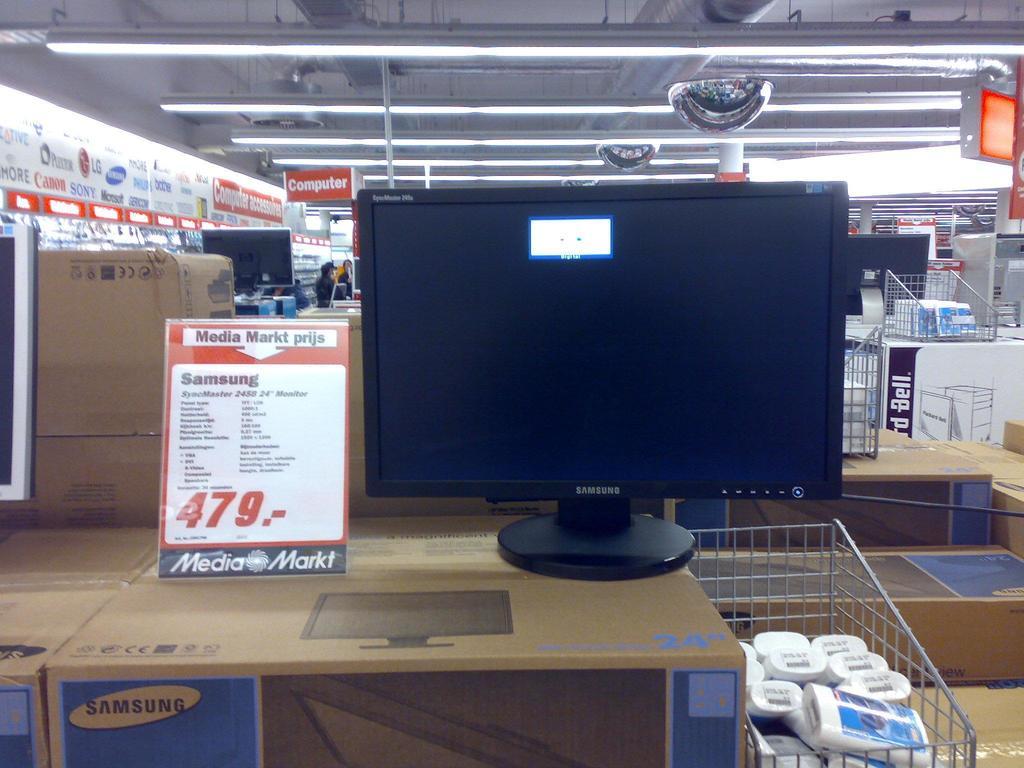Is that a samsung monitor?
Your response must be concise. Yes. What brand of monitor is this?
Your response must be concise. Samsung. 